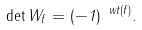Convert formula to latex. <formula><loc_0><loc_0><loc_500><loc_500>\det W _ { f } = ( - 1 ) ^ { \ w t ( f ) } .</formula> 